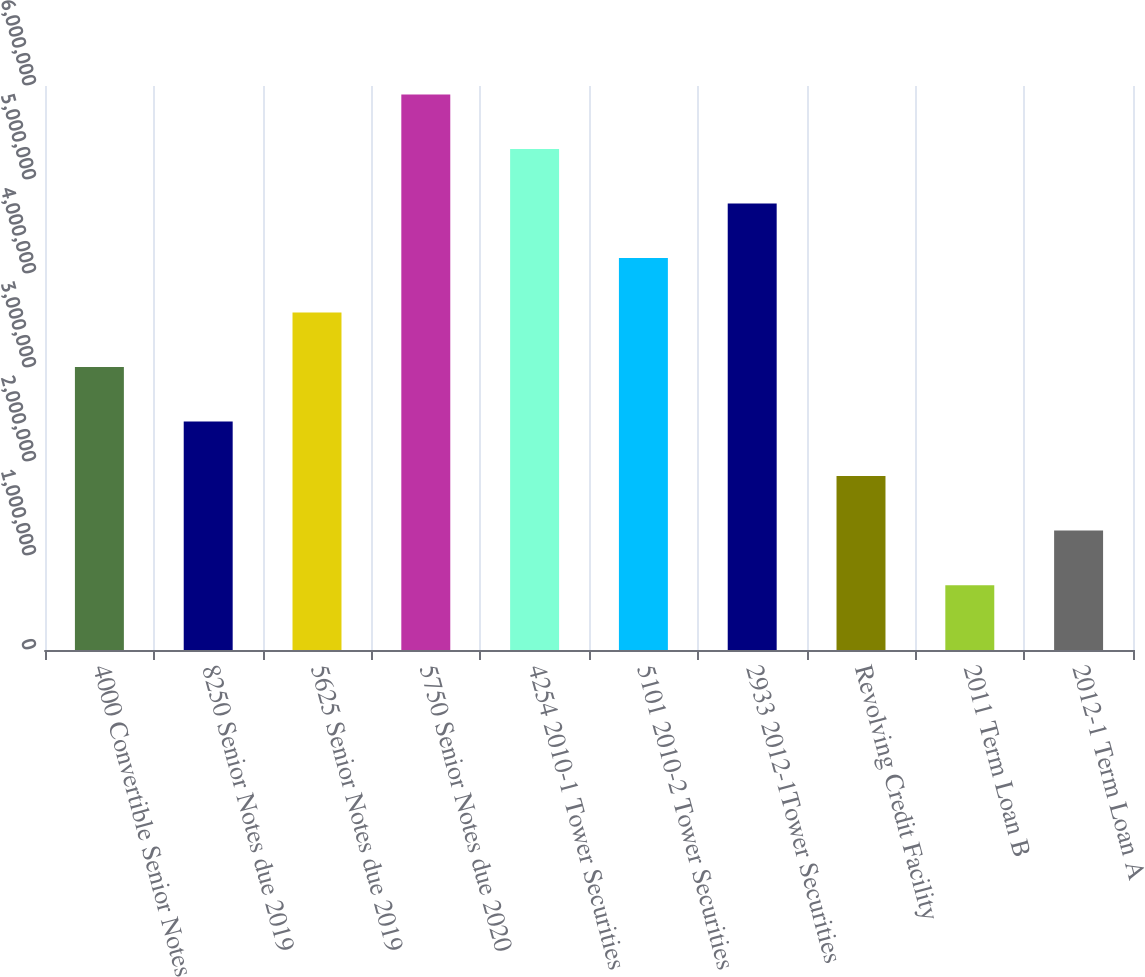Convert chart. <chart><loc_0><loc_0><loc_500><loc_500><bar_chart><fcel>4000 Convertible Senior Notes<fcel>8250 Senior Notes due 2019<fcel>5625 Senior Notes due 2019<fcel>5750 Senior Notes due 2020<fcel>4254 2010-1 Tower Securities<fcel>5101 2010-2 Tower Securities<fcel>2933 2012-1Tower Securities<fcel>Revolving Credit Facility<fcel>2011 Term Loan B<fcel>2012-1 Term Loan A<nl><fcel>3.01001e+06<fcel>2.43e+06<fcel>3.59001e+06<fcel>5.91004e+06<fcel>5.33003e+06<fcel>4.17002e+06<fcel>4.75003e+06<fcel>1.84999e+06<fcel>689978<fcel>1.26998e+06<nl></chart> 